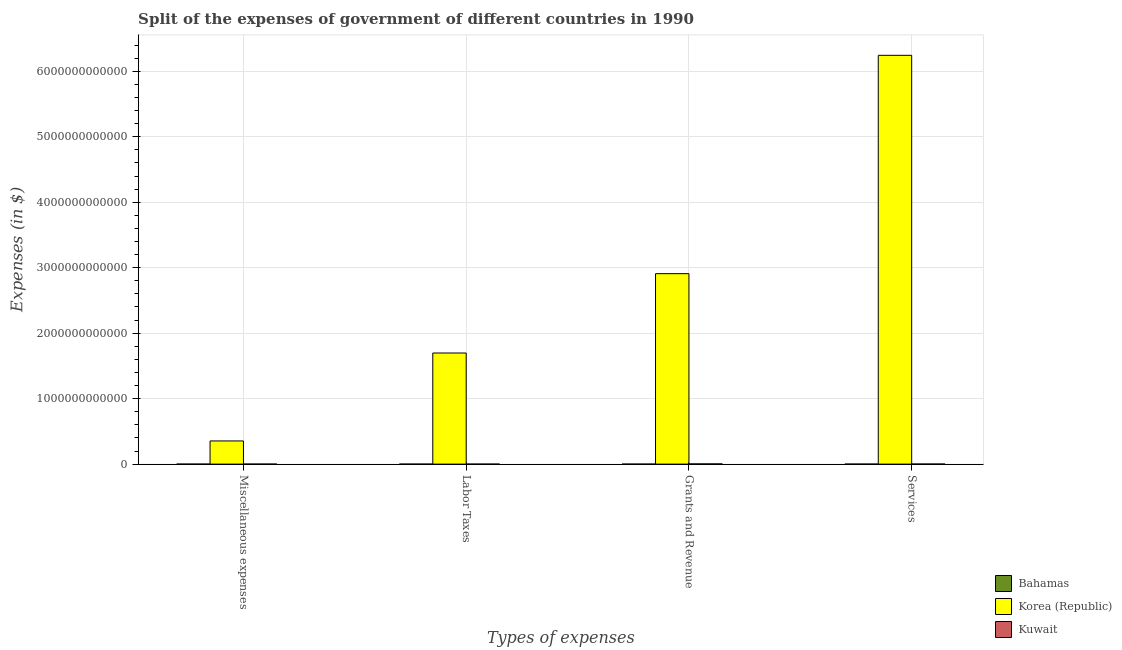How many different coloured bars are there?
Give a very brief answer. 3. How many groups of bars are there?
Offer a very short reply. 4. Are the number of bars per tick equal to the number of legend labels?
Make the answer very short. Yes. How many bars are there on the 1st tick from the left?
Your answer should be very brief. 3. How many bars are there on the 1st tick from the right?
Provide a short and direct response. 3. What is the label of the 4th group of bars from the left?
Your response must be concise. Services. What is the amount spent on labor taxes in Bahamas?
Provide a short and direct response. 6.02e+07. Across all countries, what is the maximum amount spent on services?
Offer a very short reply. 6.24e+12. Across all countries, what is the minimum amount spent on services?
Make the answer very short. 1.10e+08. In which country was the amount spent on grants and revenue maximum?
Provide a succinct answer. Korea (Republic). In which country was the amount spent on services minimum?
Give a very brief answer. Bahamas. What is the total amount spent on miscellaneous expenses in the graph?
Your response must be concise. 3.54e+11. What is the difference between the amount spent on labor taxes in Bahamas and that in Kuwait?
Keep it short and to the point. 5.82e+07. What is the difference between the amount spent on services in Korea (Republic) and the amount spent on miscellaneous expenses in Bahamas?
Your answer should be compact. 6.24e+12. What is the average amount spent on services per country?
Provide a succinct answer. 2.08e+12. What is the difference between the amount spent on labor taxes and amount spent on miscellaneous expenses in Korea (Republic)?
Offer a very short reply. 1.34e+12. In how many countries, is the amount spent on grants and revenue greater than 1800000000000 $?
Offer a very short reply. 1. What is the ratio of the amount spent on labor taxes in Korea (Republic) to that in Kuwait?
Your answer should be very brief. 8.48e+05. Is the difference between the amount spent on grants and revenue in Korea (Republic) and Kuwait greater than the difference between the amount spent on services in Korea (Republic) and Kuwait?
Your answer should be compact. No. What is the difference between the highest and the second highest amount spent on miscellaneous expenses?
Make the answer very short. 3.54e+11. What is the difference between the highest and the lowest amount spent on labor taxes?
Ensure brevity in your answer.  1.70e+12. What does the 3rd bar from the left in Miscellaneous expenses represents?
Your response must be concise. Kuwait. What does the 3rd bar from the right in Services represents?
Offer a very short reply. Bahamas. Is it the case that in every country, the sum of the amount spent on miscellaneous expenses and amount spent on labor taxes is greater than the amount spent on grants and revenue?
Offer a very short reply. No. How many bars are there?
Provide a succinct answer. 12. What is the difference between two consecutive major ticks on the Y-axis?
Make the answer very short. 1.00e+12. How many legend labels are there?
Your response must be concise. 3. What is the title of the graph?
Offer a very short reply. Split of the expenses of government of different countries in 1990. What is the label or title of the X-axis?
Ensure brevity in your answer.  Types of expenses. What is the label or title of the Y-axis?
Offer a terse response. Expenses (in $). What is the Expenses (in $) of Bahamas in Miscellaneous expenses?
Ensure brevity in your answer.  3.28e+07. What is the Expenses (in $) of Korea (Republic) in Miscellaneous expenses?
Offer a very short reply. 3.54e+11. What is the Expenses (in $) of Kuwait in Miscellaneous expenses?
Ensure brevity in your answer.  1.56e+08. What is the Expenses (in $) in Bahamas in Labor Taxes?
Provide a short and direct response. 6.02e+07. What is the Expenses (in $) of Korea (Republic) in Labor Taxes?
Ensure brevity in your answer.  1.70e+12. What is the Expenses (in $) of Bahamas in Grants and Revenue?
Provide a short and direct response. 5.94e+07. What is the Expenses (in $) in Korea (Republic) in Grants and Revenue?
Offer a terse response. 2.91e+12. What is the Expenses (in $) of Kuwait in Grants and Revenue?
Give a very brief answer. 3.03e+09. What is the Expenses (in $) of Bahamas in Services?
Your answer should be compact. 1.10e+08. What is the Expenses (in $) of Korea (Republic) in Services?
Make the answer very short. 6.24e+12. What is the Expenses (in $) of Kuwait in Services?
Ensure brevity in your answer.  8.26e+08. Across all Types of expenses, what is the maximum Expenses (in $) in Bahamas?
Your response must be concise. 1.10e+08. Across all Types of expenses, what is the maximum Expenses (in $) in Korea (Republic)?
Provide a short and direct response. 6.24e+12. Across all Types of expenses, what is the maximum Expenses (in $) in Kuwait?
Your response must be concise. 3.03e+09. Across all Types of expenses, what is the minimum Expenses (in $) in Bahamas?
Provide a short and direct response. 3.28e+07. Across all Types of expenses, what is the minimum Expenses (in $) of Korea (Republic)?
Keep it short and to the point. 3.54e+11. What is the total Expenses (in $) of Bahamas in the graph?
Ensure brevity in your answer.  2.62e+08. What is the total Expenses (in $) of Korea (Republic) in the graph?
Offer a terse response. 1.12e+13. What is the total Expenses (in $) in Kuwait in the graph?
Ensure brevity in your answer.  4.02e+09. What is the difference between the Expenses (in $) in Bahamas in Miscellaneous expenses and that in Labor Taxes?
Offer a very short reply. -2.74e+07. What is the difference between the Expenses (in $) in Korea (Republic) in Miscellaneous expenses and that in Labor Taxes?
Ensure brevity in your answer.  -1.34e+12. What is the difference between the Expenses (in $) in Kuwait in Miscellaneous expenses and that in Labor Taxes?
Your answer should be compact. 1.54e+08. What is the difference between the Expenses (in $) in Bahamas in Miscellaneous expenses and that in Grants and Revenue?
Make the answer very short. -2.66e+07. What is the difference between the Expenses (in $) of Korea (Republic) in Miscellaneous expenses and that in Grants and Revenue?
Your answer should be compact. -2.56e+12. What is the difference between the Expenses (in $) of Kuwait in Miscellaneous expenses and that in Grants and Revenue?
Provide a succinct answer. -2.88e+09. What is the difference between the Expenses (in $) in Bahamas in Miscellaneous expenses and that in Services?
Your answer should be very brief. -7.72e+07. What is the difference between the Expenses (in $) of Korea (Republic) in Miscellaneous expenses and that in Services?
Offer a terse response. -5.89e+12. What is the difference between the Expenses (in $) in Kuwait in Miscellaneous expenses and that in Services?
Provide a short and direct response. -6.70e+08. What is the difference between the Expenses (in $) in Bahamas in Labor Taxes and that in Grants and Revenue?
Your answer should be compact. 8.00e+05. What is the difference between the Expenses (in $) of Korea (Republic) in Labor Taxes and that in Grants and Revenue?
Your answer should be compact. -1.21e+12. What is the difference between the Expenses (in $) in Kuwait in Labor Taxes and that in Grants and Revenue?
Your answer should be compact. -3.03e+09. What is the difference between the Expenses (in $) in Bahamas in Labor Taxes and that in Services?
Ensure brevity in your answer.  -4.98e+07. What is the difference between the Expenses (in $) of Korea (Republic) in Labor Taxes and that in Services?
Offer a very short reply. -4.55e+12. What is the difference between the Expenses (in $) of Kuwait in Labor Taxes and that in Services?
Provide a succinct answer. -8.24e+08. What is the difference between the Expenses (in $) in Bahamas in Grants and Revenue and that in Services?
Offer a very short reply. -5.06e+07. What is the difference between the Expenses (in $) of Korea (Republic) in Grants and Revenue and that in Services?
Provide a succinct answer. -3.34e+12. What is the difference between the Expenses (in $) in Kuwait in Grants and Revenue and that in Services?
Make the answer very short. 2.21e+09. What is the difference between the Expenses (in $) in Bahamas in Miscellaneous expenses and the Expenses (in $) in Korea (Republic) in Labor Taxes?
Your response must be concise. -1.70e+12. What is the difference between the Expenses (in $) of Bahamas in Miscellaneous expenses and the Expenses (in $) of Kuwait in Labor Taxes?
Keep it short and to the point. 3.08e+07. What is the difference between the Expenses (in $) in Korea (Republic) in Miscellaneous expenses and the Expenses (in $) in Kuwait in Labor Taxes?
Your response must be concise. 3.54e+11. What is the difference between the Expenses (in $) in Bahamas in Miscellaneous expenses and the Expenses (in $) in Korea (Republic) in Grants and Revenue?
Offer a very short reply. -2.91e+12. What is the difference between the Expenses (in $) in Bahamas in Miscellaneous expenses and the Expenses (in $) in Kuwait in Grants and Revenue?
Your response must be concise. -3.00e+09. What is the difference between the Expenses (in $) of Korea (Republic) in Miscellaneous expenses and the Expenses (in $) of Kuwait in Grants and Revenue?
Provide a succinct answer. 3.51e+11. What is the difference between the Expenses (in $) of Bahamas in Miscellaneous expenses and the Expenses (in $) of Korea (Republic) in Services?
Offer a very short reply. -6.24e+12. What is the difference between the Expenses (in $) of Bahamas in Miscellaneous expenses and the Expenses (in $) of Kuwait in Services?
Keep it short and to the point. -7.93e+08. What is the difference between the Expenses (in $) of Korea (Republic) in Miscellaneous expenses and the Expenses (in $) of Kuwait in Services?
Ensure brevity in your answer.  3.53e+11. What is the difference between the Expenses (in $) of Bahamas in Labor Taxes and the Expenses (in $) of Korea (Republic) in Grants and Revenue?
Your answer should be very brief. -2.91e+12. What is the difference between the Expenses (in $) of Bahamas in Labor Taxes and the Expenses (in $) of Kuwait in Grants and Revenue?
Offer a very short reply. -2.97e+09. What is the difference between the Expenses (in $) of Korea (Republic) in Labor Taxes and the Expenses (in $) of Kuwait in Grants and Revenue?
Offer a terse response. 1.69e+12. What is the difference between the Expenses (in $) of Bahamas in Labor Taxes and the Expenses (in $) of Korea (Republic) in Services?
Give a very brief answer. -6.24e+12. What is the difference between the Expenses (in $) in Bahamas in Labor Taxes and the Expenses (in $) in Kuwait in Services?
Provide a succinct answer. -7.66e+08. What is the difference between the Expenses (in $) of Korea (Republic) in Labor Taxes and the Expenses (in $) of Kuwait in Services?
Offer a very short reply. 1.70e+12. What is the difference between the Expenses (in $) of Bahamas in Grants and Revenue and the Expenses (in $) of Korea (Republic) in Services?
Offer a very short reply. -6.24e+12. What is the difference between the Expenses (in $) of Bahamas in Grants and Revenue and the Expenses (in $) of Kuwait in Services?
Keep it short and to the point. -7.67e+08. What is the difference between the Expenses (in $) in Korea (Republic) in Grants and Revenue and the Expenses (in $) in Kuwait in Services?
Give a very brief answer. 2.91e+12. What is the average Expenses (in $) in Bahamas per Types of expenses?
Offer a very short reply. 6.56e+07. What is the average Expenses (in $) in Korea (Republic) per Types of expenses?
Your answer should be compact. 2.80e+12. What is the average Expenses (in $) in Kuwait per Types of expenses?
Your answer should be very brief. 1.00e+09. What is the difference between the Expenses (in $) of Bahamas and Expenses (in $) of Korea (Republic) in Miscellaneous expenses?
Your answer should be very brief. -3.54e+11. What is the difference between the Expenses (in $) in Bahamas and Expenses (in $) in Kuwait in Miscellaneous expenses?
Your answer should be compact. -1.23e+08. What is the difference between the Expenses (in $) of Korea (Republic) and Expenses (in $) of Kuwait in Miscellaneous expenses?
Offer a terse response. 3.54e+11. What is the difference between the Expenses (in $) of Bahamas and Expenses (in $) of Korea (Republic) in Labor Taxes?
Ensure brevity in your answer.  -1.70e+12. What is the difference between the Expenses (in $) of Bahamas and Expenses (in $) of Kuwait in Labor Taxes?
Your answer should be very brief. 5.82e+07. What is the difference between the Expenses (in $) in Korea (Republic) and Expenses (in $) in Kuwait in Labor Taxes?
Provide a short and direct response. 1.70e+12. What is the difference between the Expenses (in $) in Bahamas and Expenses (in $) in Korea (Republic) in Grants and Revenue?
Give a very brief answer. -2.91e+12. What is the difference between the Expenses (in $) of Bahamas and Expenses (in $) of Kuwait in Grants and Revenue?
Ensure brevity in your answer.  -2.97e+09. What is the difference between the Expenses (in $) in Korea (Republic) and Expenses (in $) in Kuwait in Grants and Revenue?
Give a very brief answer. 2.91e+12. What is the difference between the Expenses (in $) in Bahamas and Expenses (in $) in Korea (Republic) in Services?
Your answer should be compact. -6.24e+12. What is the difference between the Expenses (in $) in Bahamas and Expenses (in $) in Kuwait in Services?
Make the answer very short. -7.16e+08. What is the difference between the Expenses (in $) of Korea (Republic) and Expenses (in $) of Kuwait in Services?
Provide a short and direct response. 6.24e+12. What is the ratio of the Expenses (in $) in Bahamas in Miscellaneous expenses to that in Labor Taxes?
Offer a terse response. 0.54. What is the ratio of the Expenses (in $) in Korea (Republic) in Miscellaneous expenses to that in Labor Taxes?
Your response must be concise. 0.21. What is the ratio of the Expenses (in $) of Bahamas in Miscellaneous expenses to that in Grants and Revenue?
Your answer should be compact. 0.55. What is the ratio of the Expenses (in $) of Korea (Republic) in Miscellaneous expenses to that in Grants and Revenue?
Offer a terse response. 0.12. What is the ratio of the Expenses (in $) in Kuwait in Miscellaneous expenses to that in Grants and Revenue?
Provide a short and direct response. 0.05. What is the ratio of the Expenses (in $) in Bahamas in Miscellaneous expenses to that in Services?
Your answer should be very brief. 0.3. What is the ratio of the Expenses (in $) in Korea (Republic) in Miscellaneous expenses to that in Services?
Give a very brief answer. 0.06. What is the ratio of the Expenses (in $) in Kuwait in Miscellaneous expenses to that in Services?
Ensure brevity in your answer.  0.19. What is the ratio of the Expenses (in $) of Bahamas in Labor Taxes to that in Grants and Revenue?
Provide a succinct answer. 1.01. What is the ratio of the Expenses (in $) of Korea (Republic) in Labor Taxes to that in Grants and Revenue?
Provide a short and direct response. 0.58. What is the ratio of the Expenses (in $) in Kuwait in Labor Taxes to that in Grants and Revenue?
Offer a very short reply. 0. What is the ratio of the Expenses (in $) in Bahamas in Labor Taxes to that in Services?
Make the answer very short. 0.55. What is the ratio of the Expenses (in $) of Korea (Republic) in Labor Taxes to that in Services?
Offer a terse response. 0.27. What is the ratio of the Expenses (in $) of Kuwait in Labor Taxes to that in Services?
Provide a succinct answer. 0. What is the ratio of the Expenses (in $) in Bahamas in Grants and Revenue to that in Services?
Your answer should be compact. 0.54. What is the ratio of the Expenses (in $) of Korea (Republic) in Grants and Revenue to that in Services?
Your answer should be very brief. 0.47. What is the ratio of the Expenses (in $) of Kuwait in Grants and Revenue to that in Services?
Provide a short and direct response. 3.67. What is the difference between the highest and the second highest Expenses (in $) in Bahamas?
Your answer should be very brief. 4.98e+07. What is the difference between the highest and the second highest Expenses (in $) in Korea (Republic)?
Your response must be concise. 3.34e+12. What is the difference between the highest and the second highest Expenses (in $) of Kuwait?
Your answer should be very brief. 2.21e+09. What is the difference between the highest and the lowest Expenses (in $) in Bahamas?
Your answer should be compact. 7.72e+07. What is the difference between the highest and the lowest Expenses (in $) of Korea (Republic)?
Offer a very short reply. 5.89e+12. What is the difference between the highest and the lowest Expenses (in $) of Kuwait?
Your answer should be very brief. 3.03e+09. 